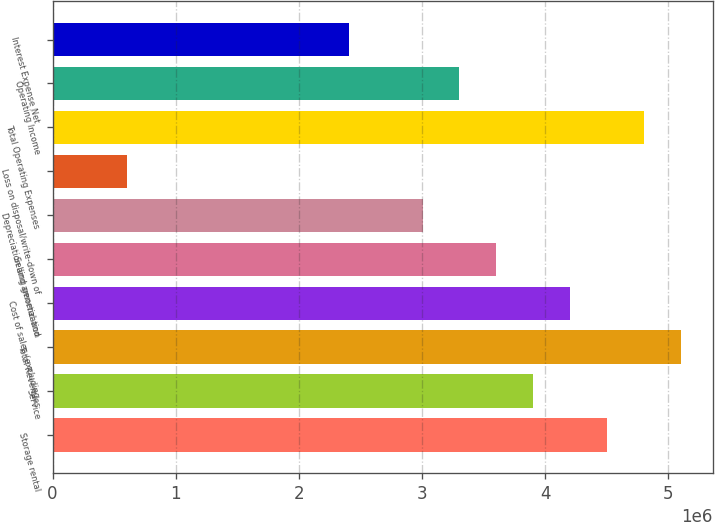Convert chart to OTSL. <chart><loc_0><loc_0><loc_500><loc_500><bar_chart><fcel>Storage rental<fcel>Service<fcel>Total Revenues<fcel>Cost of sales (excluding<fcel>Selling general and<fcel>Depreciation and amortization<fcel>Loss on disposal/write-down of<fcel>Total Operating Expenses<fcel>Operating Income<fcel>Interest Expense Net<nl><fcel>4.50583e+06<fcel>3.90508e+06<fcel>5.10658e+06<fcel>4.20545e+06<fcel>3.6047e+06<fcel>3.00396e+06<fcel>600956<fcel>4.8062e+06<fcel>3.30433e+06<fcel>2.40321e+06<nl></chart> 